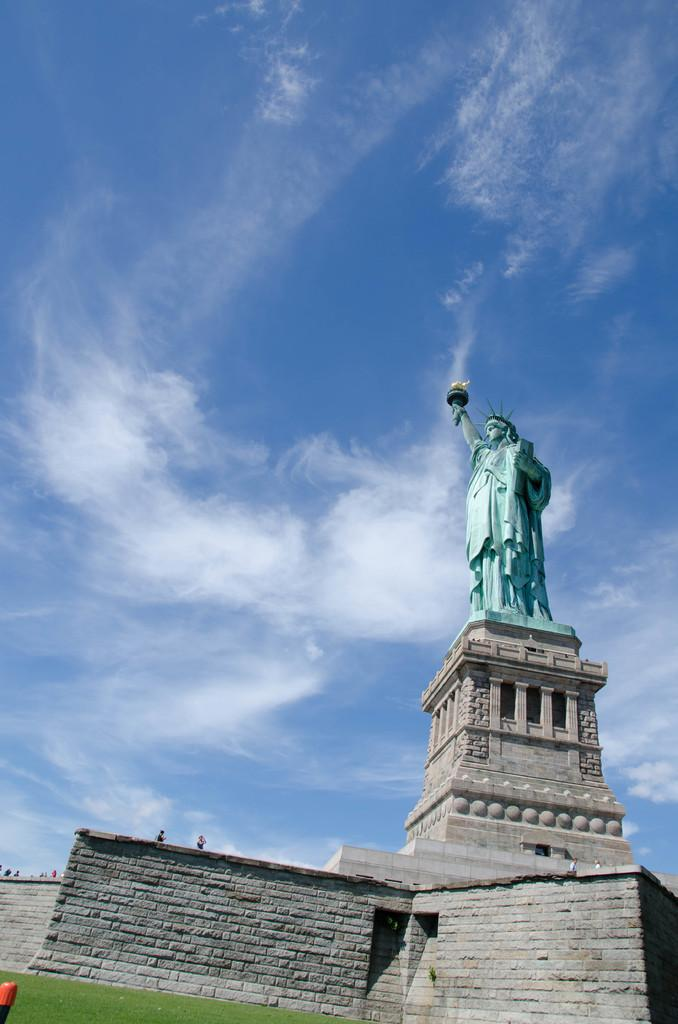What is located in the foreground of the image? There is a statue and a wall in the foreground of the image. What type of vegetation can be seen in the foreground of the image? There is grass in the foreground of the image. What is visible at the top of the image? The sky is visible at the top of the image. What can be seen in the sky in the image? There are clouds visible in the sky. What type of cloth is draped over the statue in the image? There is no cloth draped over the statue in the image; it is not mentioned in the provided facts. What reward is the statue holding in the image? There is no reward visible in the image; the statue is not holding anything. 